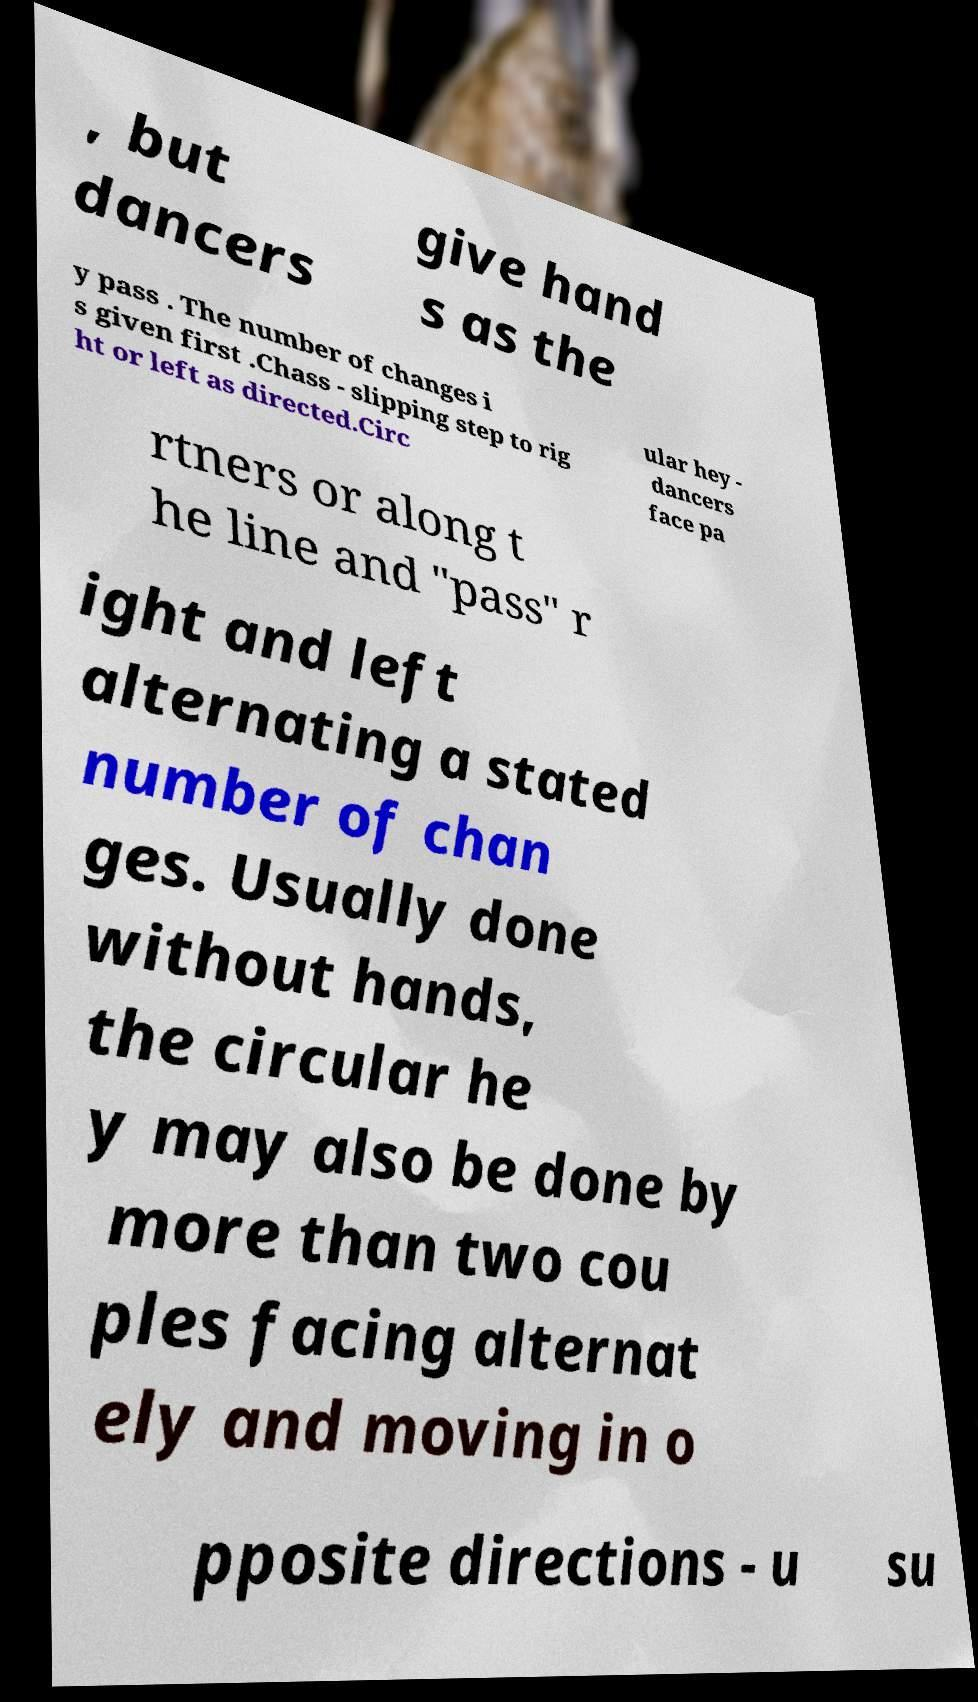Could you extract and type out the text from this image? , but dancers give hand s as the y pass . The number of changes i s given first .Chass - slipping step to rig ht or left as directed.Circ ular hey - dancers face pa rtners or along t he line and "pass" r ight and left alternating a stated number of chan ges. Usually done without hands, the circular he y may also be done by more than two cou ples facing alternat ely and moving in o pposite directions - u su 